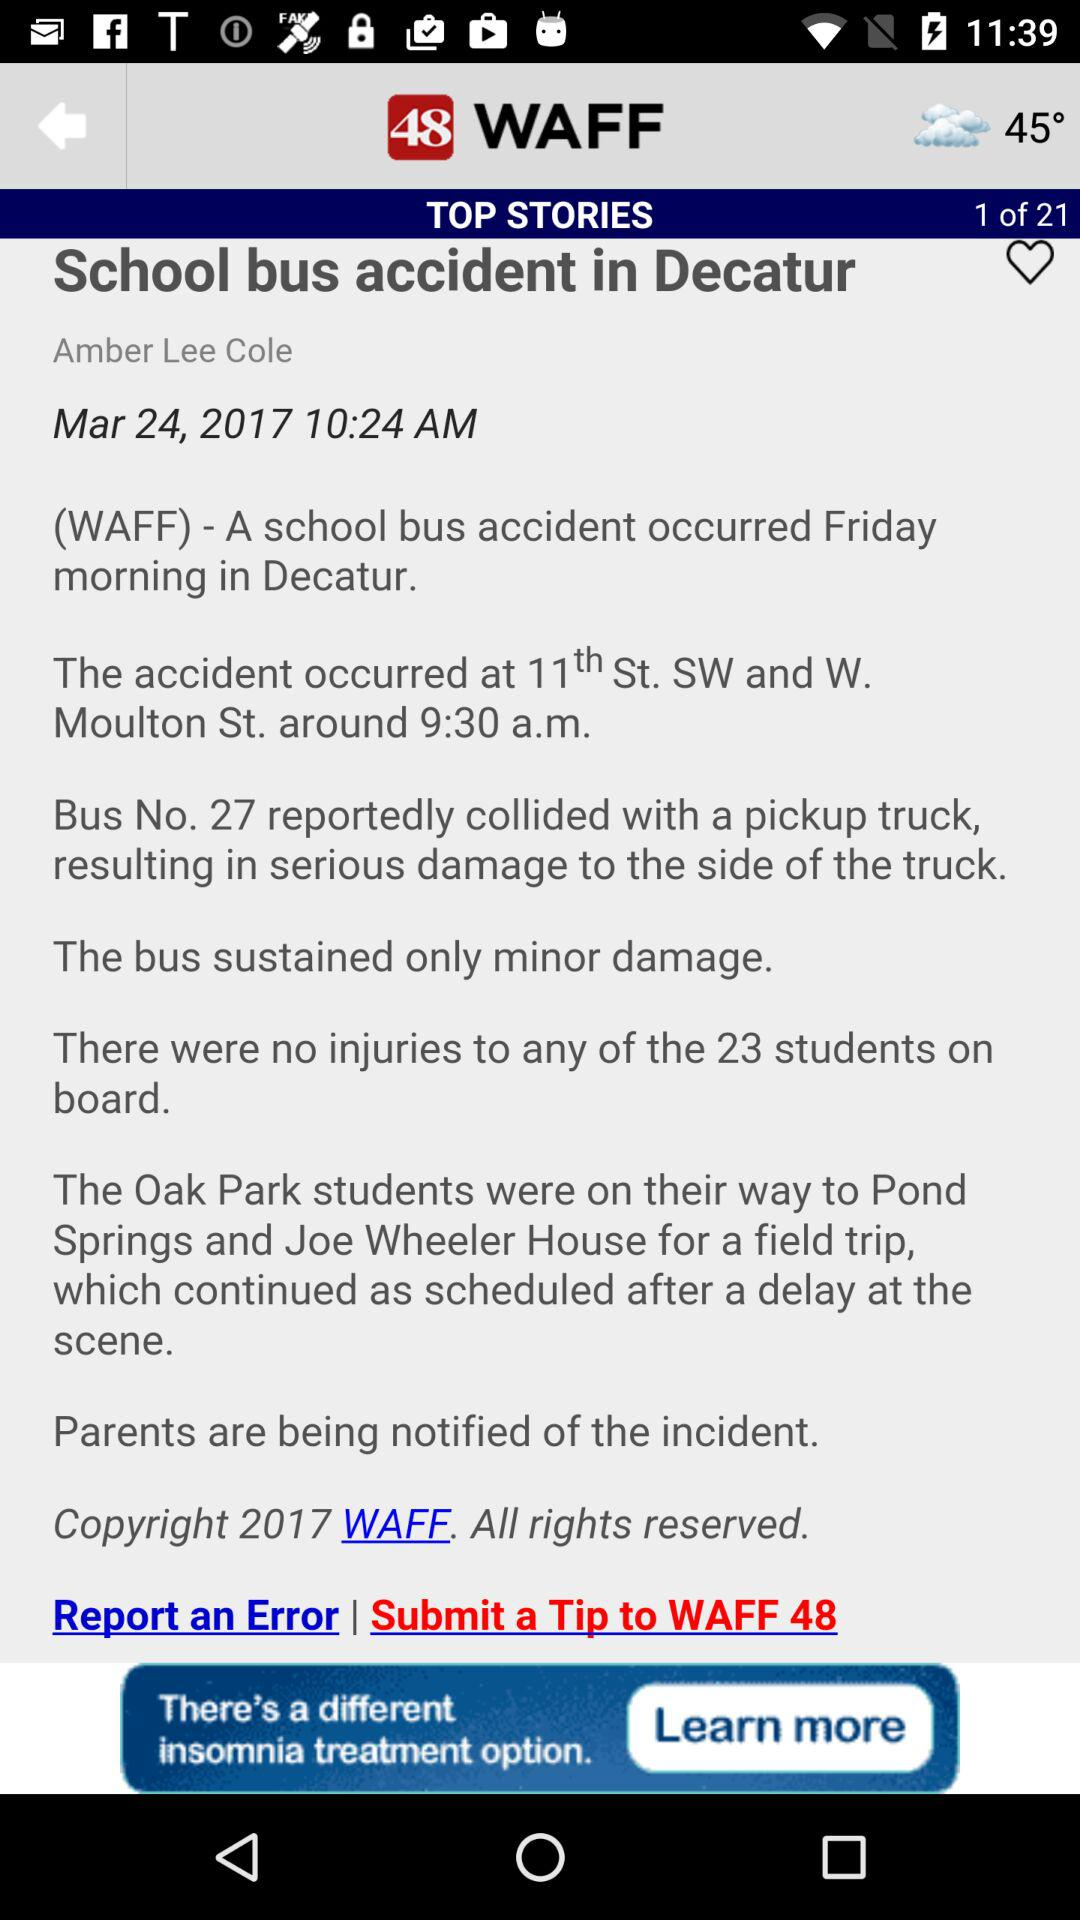What is the given date? The given date is March 24, 2017. 